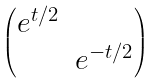<formula> <loc_0><loc_0><loc_500><loc_500>\begin{pmatrix} e ^ { t / 2 } & \\ & e ^ { - t / 2 } \end{pmatrix}</formula> 